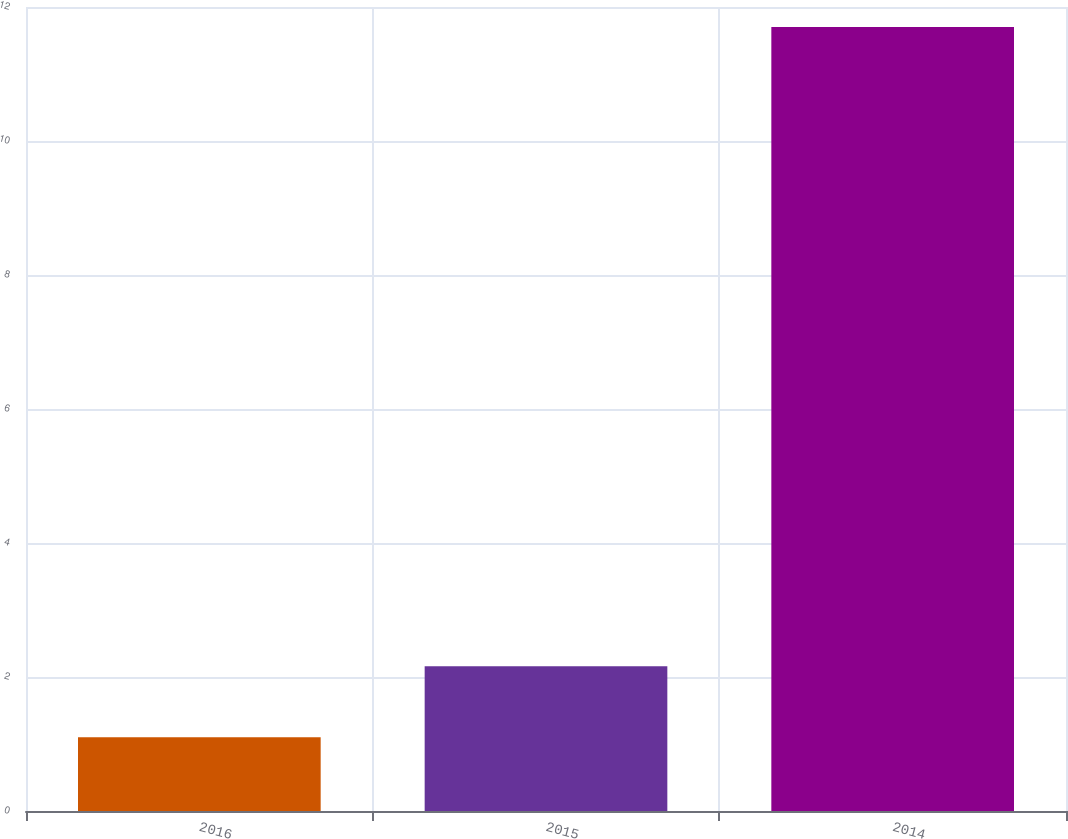Convert chart. <chart><loc_0><loc_0><loc_500><loc_500><bar_chart><fcel>2016<fcel>2015<fcel>2014<nl><fcel>1.1<fcel>2.16<fcel>11.7<nl></chart> 